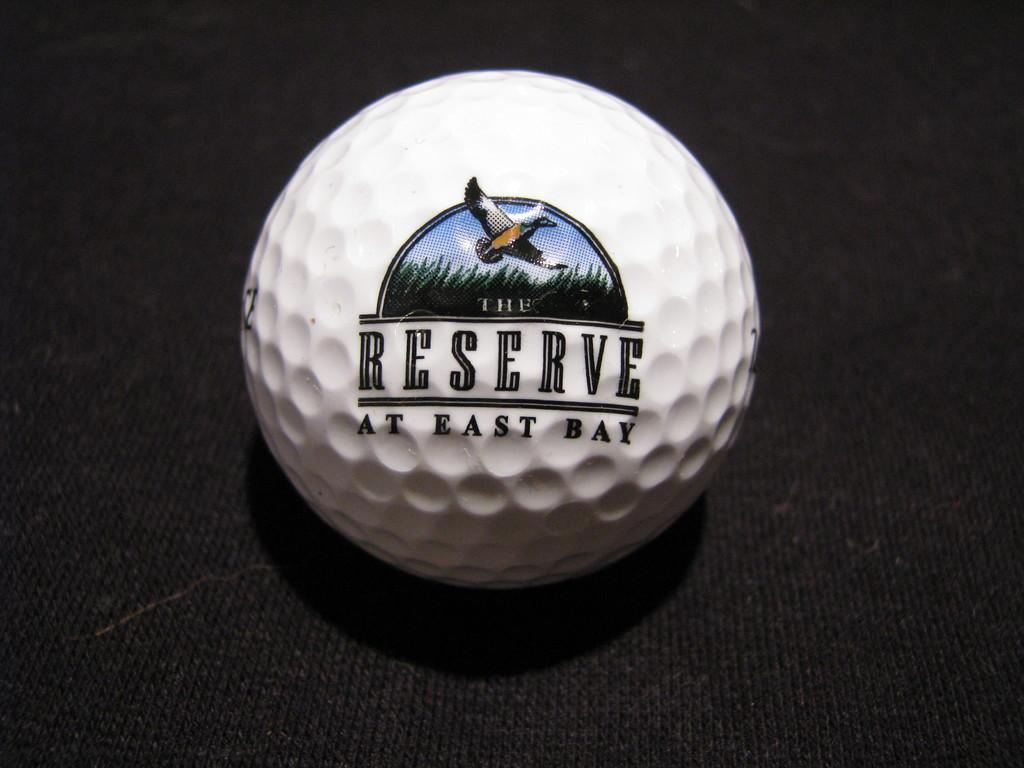What is the primary object in the image? There is a white ball in the image. What is the color of the surface the ball is on? The ball is on a black surface. What text is written on the ball? The text "RESERVE AT EAST BAY" is written on the ball. What type of mitten is shown holding the ball in the image? There is no mitten present in the image, and the ball is not being held by any object. 